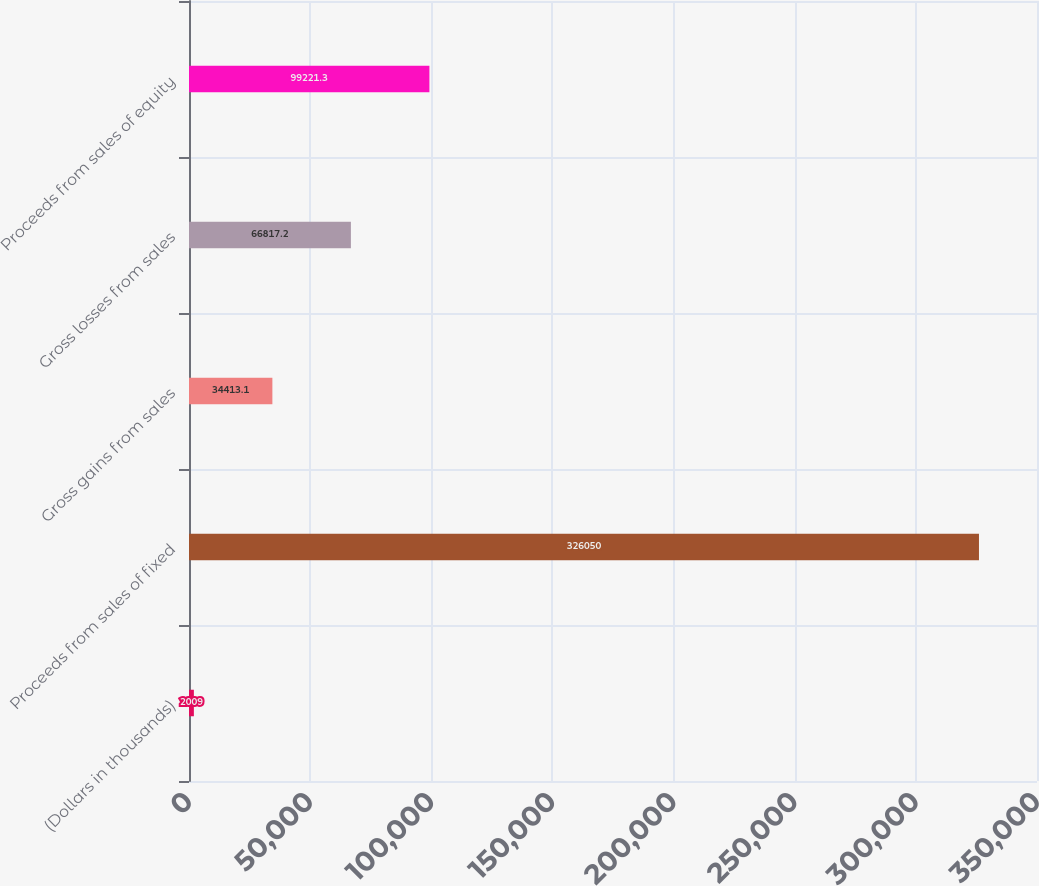<chart> <loc_0><loc_0><loc_500><loc_500><bar_chart><fcel>(Dollars in thousands)<fcel>Proceeds from sales of fixed<fcel>Gross gains from sales<fcel>Gross losses from sales<fcel>Proceeds from sales of equity<nl><fcel>2009<fcel>326050<fcel>34413.1<fcel>66817.2<fcel>99221.3<nl></chart> 